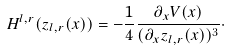<formula> <loc_0><loc_0><loc_500><loc_500>H ^ { l , r } ( z _ { l , r } ( x ) ) = - \frac { 1 } 4 \frac { \partial _ { x } V ( x ) } { ( \partial _ { x } z _ { l , r } ( x ) ) ^ { 3 } } \cdot</formula> 